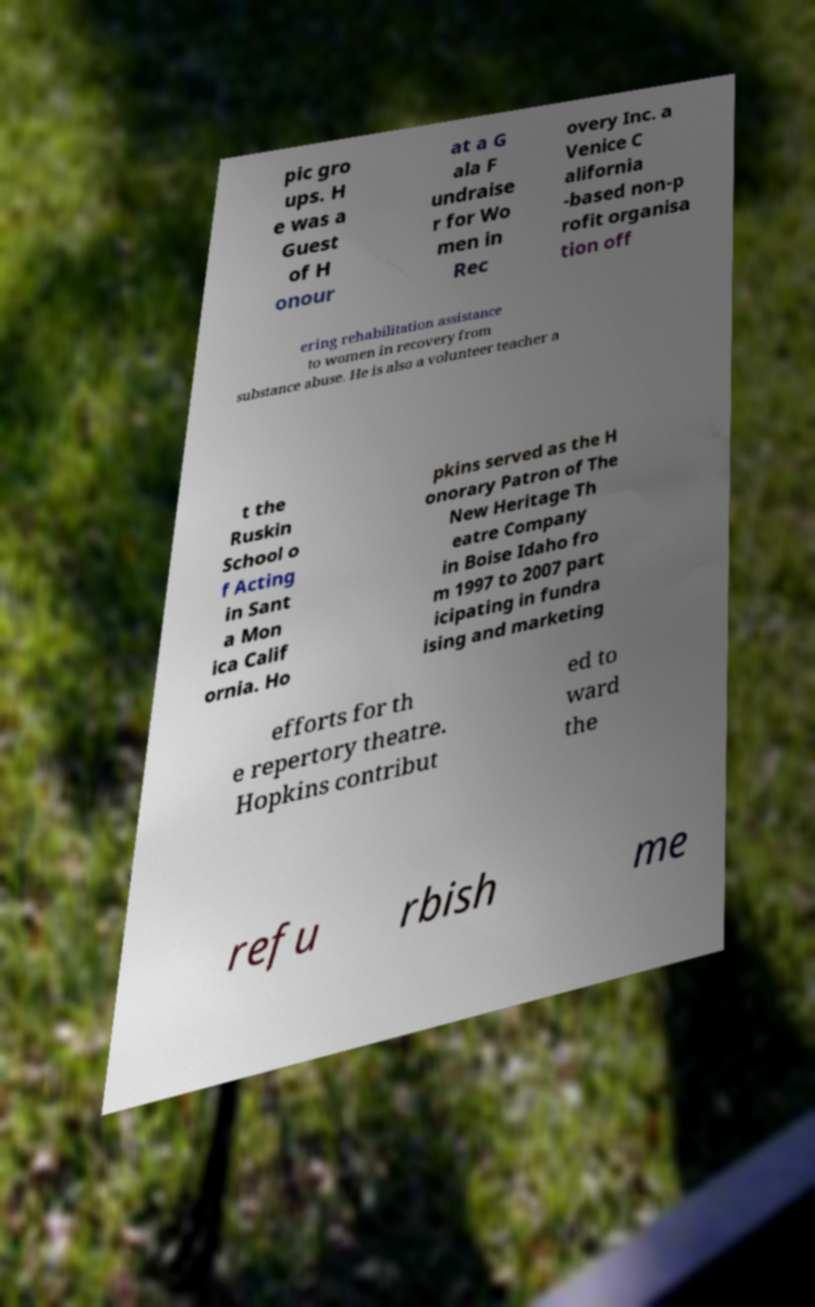What messages or text are displayed in this image? I need them in a readable, typed format. pic gro ups. H e was a Guest of H onour at a G ala F undraise r for Wo men in Rec overy Inc. a Venice C alifornia -based non-p rofit organisa tion off ering rehabilitation assistance to women in recovery from substance abuse. He is also a volunteer teacher a t the Ruskin School o f Acting in Sant a Mon ica Calif ornia. Ho pkins served as the H onorary Patron of The New Heritage Th eatre Company in Boise Idaho fro m 1997 to 2007 part icipating in fundra ising and marketing efforts for th e repertory theatre. Hopkins contribut ed to ward the refu rbish me 